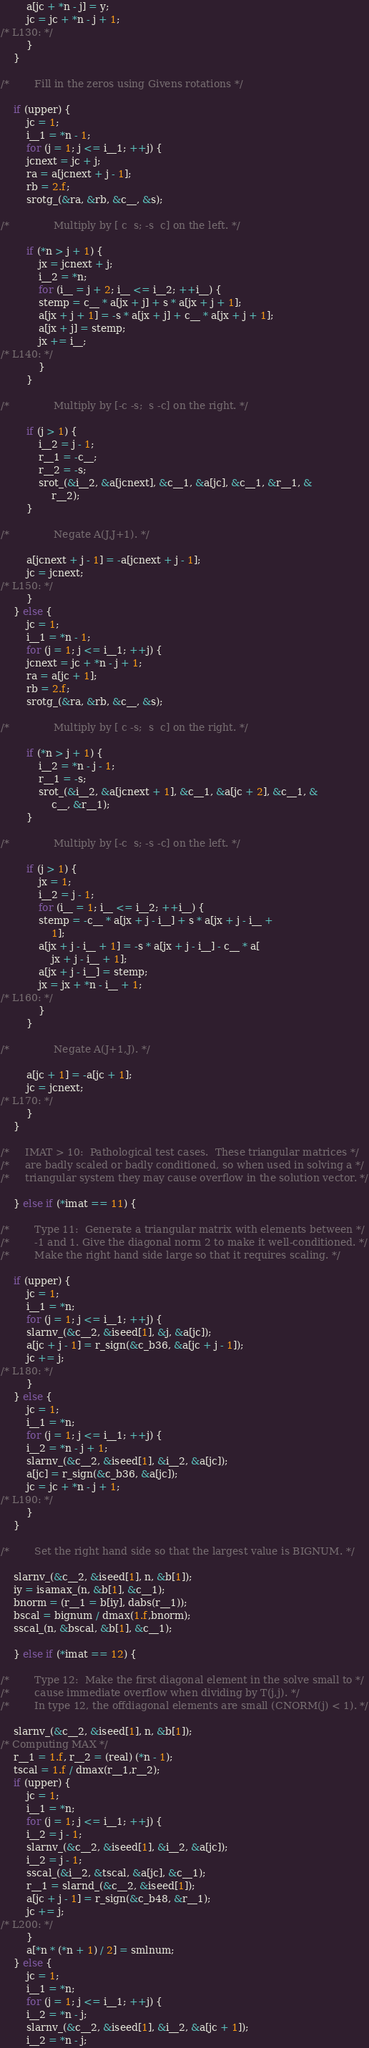Convert code to text. <code><loc_0><loc_0><loc_500><loc_500><_C_>		a[jc + *n - j] = y;
		jc = jc + *n - j + 1;
/* L130: */
	    }
	}

/*        Fill in the zeros using Givens rotations */

	if (upper) {
	    jc = 1;
	    i__1 = *n - 1;
	    for (j = 1; j <= i__1; ++j) {
		jcnext = jc + j;
		ra = a[jcnext + j - 1];
		rb = 2.f;
		srotg_(&ra, &rb, &c__, &s);

/*              Multiply by [ c  s; -s  c] on the left. */

		if (*n > j + 1) {
		    jx = jcnext + j;
		    i__2 = *n;
		    for (i__ = j + 2; i__ <= i__2; ++i__) {
			stemp = c__ * a[jx + j] + s * a[jx + j + 1];
			a[jx + j + 1] = -s * a[jx + j] + c__ * a[jx + j + 1];
			a[jx + j] = stemp;
			jx += i__;
/* L140: */
		    }
		}

/*              Multiply by [-c -s;  s -c] on the right. */

		if (j > 1) {
		    i__2 = j - 1;
		    r__1 = -c__;
		    r__2 = -s;
		    srot_(&i__2, &a[jcnext], &c__1, &a[jc], &c__1, &r__1, &
			    r__2);
		}

/*              Negate A(J,J+1). */

		a[jcnext + j - 1] = -a[jcnext + j - 1];
		jc = jcnext;
/* L150: */
	    }
	} else {
	    jc = 1;
	    i__1 = *n - 1;
	    for (j = 1; j <= i__1; ++j) {
		jcnext = jc + *n - j + 1;
		ra = a[jc + 1];
		rb = 2.f;
		srotg_(&ra, &rb, &c__, &s);

/*              Multiply by [ c -s;  s  c] on the right. */

		if (*n > j + 1) {
		    i__2 = *n - j - 1;
		    r__1 = -s;
		    srot_(&i__2, &a[jcnext + 1], &c__1, &a[jc + 2], &c__1, &
			    c__, &r__1);
		}

/*              Multiply by [-c  s; -s -c] on the left. */

		if (j > 1) {
		    jx = 1;
		    i__2 = j - 1;
		    for (i__ = 1; i__ <= i__2; ++i__) {
			stemp = -c__ * a[jx + j - i__] + s * a[jx + j - i__ + 
				1];
			a[jx + j - i__ + 1] = -s * a[jx + j - i__] - c__ * a[
				jx + j - i__ + 1];
			a[jx + j - i__] = stemp;
			jx = jx + *n - i__ + 1;
/* L160: */
		    }
		}

/*              Negate A(J+1,J). */

		a[jc + 1] = -a[jc + 1];
		jc = jcnext;
/* L170: */
	    }
	}

/*     IMAT > 10:  Pathological test cases.  These triangular matrices */
/*     are badly scaled or badly conditioned, so when used in solving a */
/*     triangular system they may cause overflow in the solution vector. */

    } else if (*imat == 11) {

/*        Type 11:  Generate a triangular matrix with elements between */
/*        -1 and 1. Give the diagonal norm 2 to make it well-conditioned. */
/*        Make the right hand side large so that it requires scaling. */

	if (upper) {
	    jc = 1;
	    i__1 = *n;
	    for (j = 1; j <= i__1; ++j) {
		slarnv_(&c__2, &iseed[1], &j, &a[jc]);
		a[jc + j - 1] = r_sign(&c_b36, &a[jc + j - 1]);
		jc += j;
/* L180: */
	    }
	} else {
	    jc = 1;
	    i__1 = *n;
	    for (j = 1; j <= i__1; ++j) {
		i__2 = *n - j + 1;
		slarnv_(&c__2, &iseed[1], &i__2, &a[jc]);
		a[jc] = r_sign(&c_b36, &a[jc]);
		jc = jc + *n - j + 1;
/* L190: */
	    }
	}

/*        Set the right hand side so that the largest value is BIGNUM. */

	slarnv_(&c__2, &iseed[1], n, &b[1]);
	iy = isamax_(n, &b[1], &c__1);
	bnorm = (r__1 = b[iy], dabs(r__1));
	bscal = bignum / dmax(1.f,bnorm);
	sscal_(n, &bscal, &b[1], &c__1);

    } else if (*imat == 12) {

/*        Type 12:  Make the first diagonal element in the solve small to */
/*        cause immediate overflow when dividing by T(j,j). */
/*        In type 12, the offdiagonal elements are small (CNORM(j) < 1). */

	slarnv_(&c__2, &iseed[1], n, &b[1]);
/* Computing MAX */
	r__1 = 1.f, r__2 = (real) (*n - 1);
	tscal = 1.f / dmax(r__1,r__2);
	if (upper) {
	    jc = 1;
	    i__1 = *n;
	    for (j = 1; j <= i__1; ++j) {
		i__2 = j - 1;
		slarnv_(&c__2, &iseed[1], &i__2, &a[jc]);
		i__2 = j - 1;
		sscal_(&i__2, &tscal, &a[jc], &c__1);
		r__1 = slarnd_(&c__2, &iseed[1]);
		a[jc + j - 1] = r_sign(&c_b48, &r__1);
		jc += j;
/* L200: */
	    }
	    a[*n * (*n + 1) / 2] = smlnum;
	} else {
	    jc = 1;
	    i__1 = *n;
	    for (j = 1; j <= i__1; ++j) {
		i__2 = *n - j;
		slarnv_(&c__2, &iseed[1], &i__2, &a[jc + 1]);
		i__2 = *n - j;</code> 